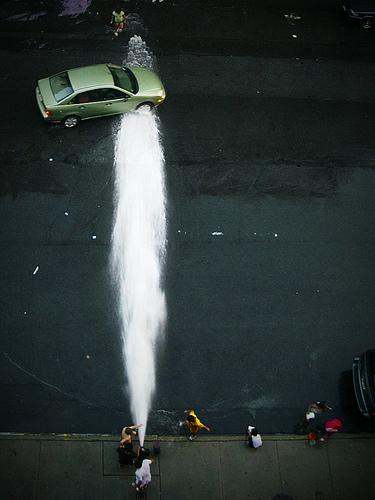What is the water coming out of?
Answer briefly. Hydrant. What color is the car?
Answer briefly. Green. What is being sprayed?
Write a very short answer. Water. 